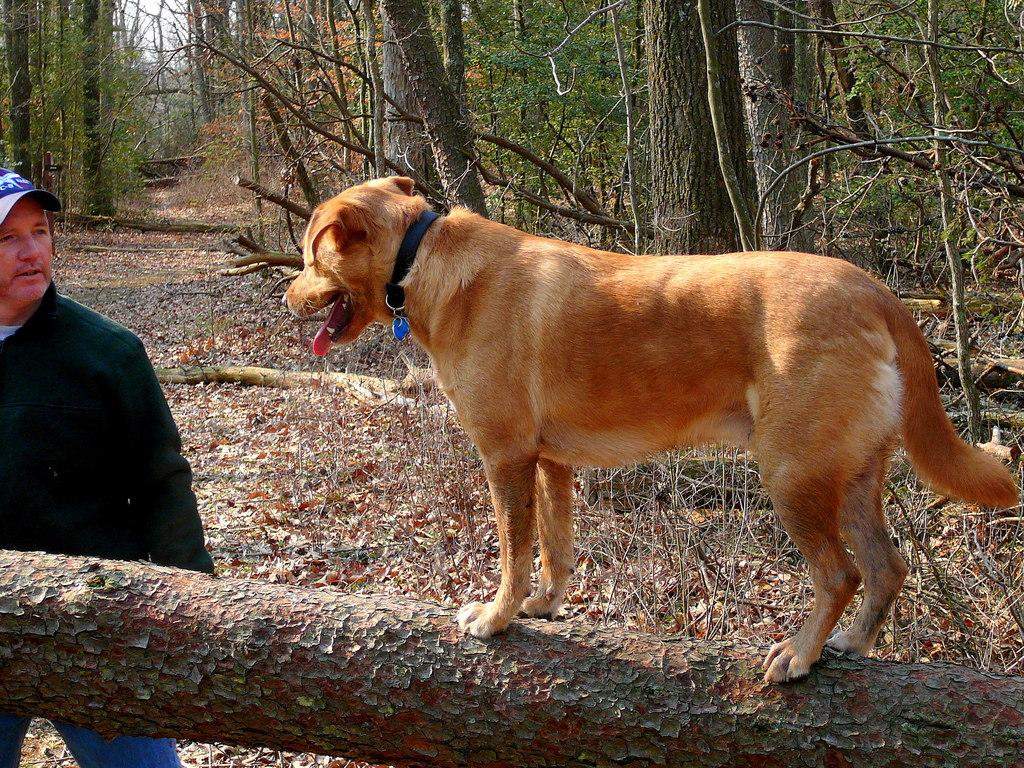What type of animal is in the image? There is a brown dog in the image. Where is the dog located in the image? The dog is on a branch of a tree. Who else is in the image besides the dog? There is a man in the image. What is the man doing in the image? The man is looking at the dog. What is the man wearing on his head? The man is wearing a cap. What type of patch can be seen on the dog's fur in the image? There is no patch visible on the dog's fur in the image. What crime has the man committed, as indicated by the crook in the image? There is no crook or indication of criminal activity in the image. 